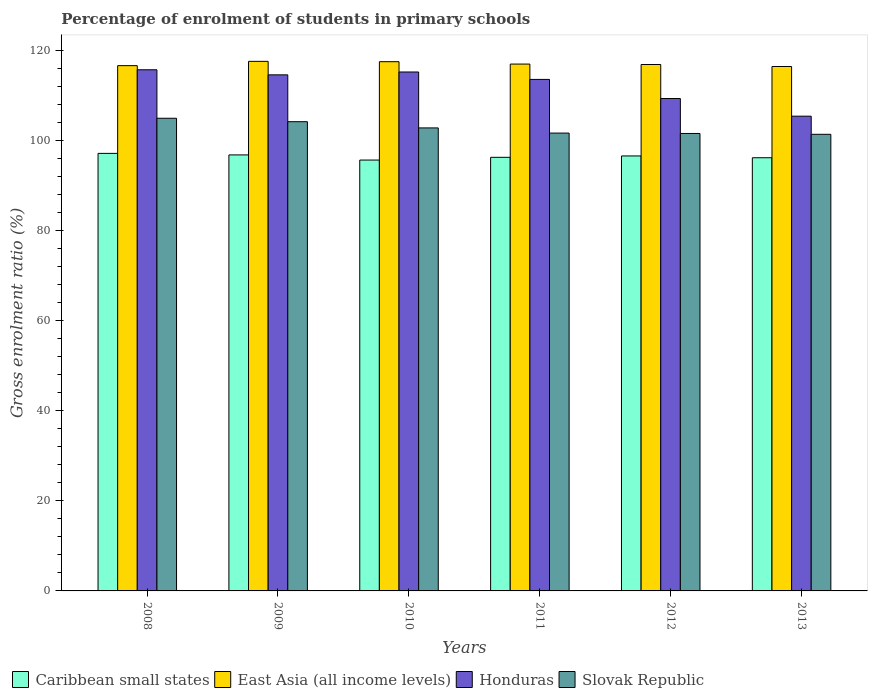Are the number of bars per tick equal to the number of legend labels?
Keep it short and to the point. Yes. How many bars are there on the 5th tick from the right?
Provide a succinct answer. 4. What is the percentage of students enrolled in primary schools in East Asia (all income levels) in 2012?
Make the answer very short. 116.97. Across all years, what is the maximum percentage of students enrolled in primary schools in Honduras?
Make the answer very short. 115.8. Across all years, what is the minimum percentage of students enrolled in primary schools in Caribbean small states?
Ensure brevity in your answer.  95.74. In which year was the percentage of students enrolled in primary schools in Slovak Republic maximum?
Make the answer very short. 2008. In which year was the percentage of students enrolled in primary schools in Caribbean small states minimum?
Your response must be concise. 2010. What is the total percentage of students enrolled in primary schools in Caribbean small states in the graph?
Provide a succinct answer. 579.08. What is the difference between the percentage of students enrolled in primary schools in Caribbean small states in 2010 and that in 2011?
Your answer should be compact. -0.61. What is the difference between the percentage of students enrolled in primary schools in Honduras in 2008 and the percentage of students enrolled in primary schools in Slovak Republic in 2013?
Provide a short and direct response. 14.34. What is the average percentage of students enrolled in primary schools in Caribbean small states per year?
Give a very brief answer. 96.51. In the year 2008, what is the difference between the percentage of students enrolled in primary schools in Slovak Republic and percentage of students enrolled in primary schools in East Asia (all income levels)?
Provide a succinct answer. -11.69. What is the ratio of the percentage of students enrolled in primary schools in Slovak Republic in 2009 to that in 2012?
Your answer should be very brief. 1.03. Is the difference between the percentage of students enrolled in primary schools in Slovak Republic in 2008 and 2013 greater than the difference between the percentage of students enrolled in primary schools in East Asia (all income levels) in 2008 and 2013?
Your answer should be compact. Yes. What is the difference between the highest and the second highest percentage of students enrolled in primary schools in Caribbean small states?
Provide a succinct answer. 0.34. What is the difference between the highest and the lowest percentage of students enrolled in primary schools in Slovak Republic?
Keep it short and to the point. 3.56. In how many years, is the percentage of students enrolled in primary schools in Caribbean small states greater than the average percentage of students enrolled in primary schools in Caribbean small states taken over all years?
Keep it short and to the point. 3. Is the sum of the percentage of students enrolled in primary schools in Honduras in 2009 and 2011 greater than the maximum percentage of students enrolled in primary schools in Caribbean small states across all years?
Provide a short and direct response. Yes. What does the 4th bar from the left in 2009 represents?
Keep it short and to the point. Slovak Republic. What does the 1st bar from the right in 2012 represents?
Keep it short and to the point. Slovak Republic. How many bars are there?
Provide a short and direct response. 24. Are all the bars in the graph horizontal?
Your answer should be very brief. No. What is the difference between two consecutive major ticks on the Y-axis?
Offer a very short reply. 20. Are the values on the major ticks of Y-axis written in scientific E-notation?
Give a very brief answer. No. How many legend labels are there?
Provide a succinct answer. 4. How are the legend labels stacked?
Your answer should be very brief. Horizontal. What is the title of the graph?
Offer a very short reply. Percentage of enrolment of students in primary schools. What is the label or title of the Y-axis?
Provide a succinct answer. Gross enrolment ratio (%). What is the Gross enrolment ratio (%) in Caribbean small states in 2008?
Ensure brevity in your answer.  97.22. What is the Gross enrolment ratio (%) in East Asia (all income levels) in 2008?
Offer a very short reply. 116.71. What is the Gross enrolment ratio (%) in Honduras in 2008?
Ensure brevity in your answer.  115.8. What is the Gross enrolment ratio (%) in Slovak Republic in 2008?
Make the answer very short. 105.02. What is the Gross enrolment ratio (%) in Caribbean small states in 2009?
Offer a very short reply. 96.88. What is the Gross enrolment ratio (%) of East Asia (all income levels) in 2009?
Make the answer very short. 117.67. What is the Gross enrolment ratio (%) of Honduras in 2009?
Offer a terse response. 114.67. What is the Gross enrolment ratio (%) in Slovak Republic in 2009?
Your response must be concise. 104.26. What is the Gross enrolment ratio (%) in Caribbean small states in 2010?
Keep it short and to the point. 95.74. What is the Gross enrolment ratio (%) in East Asia (all income levels) in 2010?
Provide a succinct answer. 117.59. What is the Gross enrolment ratio (%) in Honduras in 2010?
Give a very brief answer. 115.31. What is the Gross enrolment ratio (%) of Slovak Republic in 2010?
Your answer should be very brief. 102.88. What is the Gross enrolment ratio (%) in Caribbean small states in 2011?
Your answer should be very brief. 96.34. What is the Gross enrolment ratio (%) of East Asia (all income levels) in 2011?
Provide a succinct answer. 117.07. What is the Gross enrolment ratio (%) in Honduras in 2011?
Ensure brevity in your answer.  113.66. What is the Gross enrolment ratio (%) in Slovak Republic in 2011?
Make the answer very short. 101.73. What is the Gross enrolment ratio (%) of Caribbean small states in 2012?
Keep it short and to the point. 96.65. What is the Gross enrolment ratio (%) in East Asia (all income levels) in 2012?
Your response must be concise. 116.97. What is the Gross enrolment ratio (%) in Honduras in 2012?
Keep it short and to the point. 109.41. What is the Gross enrolment ratio (%) in Slovak Republic in 2012?
Make the answer very short. 101.65. What is the Gross enrolment ratio (%) in Caribbean small states in 2013?
Offer a very short reply. 96.25. What is the Gross enrolment ratio (%) in East Asia (all income levels) in 2013?
Ensure brevity in your answer.  116.52. What is the Gross enrolment ratio (%) in Honduras in 2013?
Give a very brief answer. 105.49. What is the Gross enrolment ratio (%) of Slovak Republic in 2013?
Your answer should be very brief. 101.46. Across all years, what is the maximum Gross enrolment ratio (%) of Caribbean small states?
Offer a very short reply. 97.22. Across all years, what is the maximum Gross enrolment ratio (%) of East Asia (all income levels)?
Make the answer very short. 117.67. Across all years, what is the maximum Gross enrolment ratio (%) in Honduras?
Give a very brief answer. 115.8. Across all years, what is the maximum Gross enrolment ratio (%) in Slovak Republic?
Your answer should be compact. 105.02. Across all years, what is the minimum Gross enrolment ratio (%) in Caribbean small states?
Offer a terse response. 95.74. Across all years, what is the minimum Gross enrolment ratio (%) in East Asia (all income levels)?
Offer a terse response. 116.52. Across all years, what is the minimum Gross enrolment ratio (%) in Honduras?
Provide a short and direct response. 105.49. Across all years, what is the minimum Gross enrolment ratio (%) in Slovak Republic?
Offer a very short reply. 101.46. What is the total Gross enrolment ratio (%) of Caribbean small states in the graph?
Your response must be concise. 579.08. What is the total Gross enrolment ratio (%) in East Asia (all income levels) in the graph?
Provide a succinct answer. 702.53. What is the total Gross enrolment ratio (%) of Honduras in the graph?
Ensure brevity in your answer.  674.33. What is the total Gross enrolment ratio (%) in Slovak Republic in the graph?
Your answer should be compact. 617. What is the difference between the Gross enrolment ratio (%) of Caribbean small states in 2008 and that in 2009?
Provide a short and direct response. 0.34. What is the difference between the Gross enrolment ratio (%) in East Asia (all income levels) in 2008 and that in 2009?
Offer a terse response. -0.95. What is the difference between the Gross enrolment ratio (%) of Honduras in 2008 and that in 2009?
Provide a succinct answer. 1.13. What is the difference between the Gross enrolment ratio (%) in Slovak Republic in 2008 and that in 2009?
Offer a very short reply. 0.76. What is the difference between the Gross enrolment ratio (%) in Caribbean small states in 2008 and that in 2010?
Make the answer very short. 1.48. What is the difference between the Gross enrolment ratio (%) in East Asia (all income levels) in 2008 and that in 2010?
Your response must be concise. -0.88. What is the difference between the Gross enrolment ratio (%) in Honduras in 2008 and that in 2010?
Make the answer very short. 0.49. What is the difference between the Gross enrolment ratio (%) in Slovak Republic in 2008 and that in 2010?
Your answer should be very brief. 2.14. What is the difference between the Gross enrolment ratio (%) of Caribbean small states in 2008 and that in 2011?
Make the answer very short. 0.88. What is the difference between the Gross enrolment ratio (%) of East Asia (all income levels) in 2008 and that in 2011?
Your response must be concise. -0.35. What is the difference between the Gross enrolment ratio (%) in Honduras in 2008 and that in 2011?
Your answer should be compact. 2.14. What is the difference between the Gross enrolment ratio (%) in Slovak Republic in 2008 and that in 2011?
Your response must be concise. 3.29. What is the difference between the Gross enrolment ratio (%) of Caribbean small states in 2008 and that in 2012?
Provide a succinct answer. 0.57. What is the difference between the Gross enrolment ratio (%) of East Asia (all income levels) in 2008 and that in 2012?
Your answer should be very brief. -0.25. What is the difference between the Gross enrolment ratio (%) of Honduras in 2008 and that in 2012?
Your answer should be compact. 6.39. What is the difference between the Gross enrolment ratio (%) of Slovak Republic in 2008 and that in 2012?
Provide a short and direct response. 3.38. What is the difference between the Gross enrolment ratio (%) of Caribbean small states in 2008 and that in 2013?
Make the answer very short. 0.97. What is the difference between the Gross enrolment ratio (%) of East Asia (all income levels) in 2008 and that in 2013?
Your answer should be compact. 0.19. What is the difference between the Gross enrolment ratio (%) of Honduras in 2008 and that in 2013?
Your answer should be very brief. 10.31. What is the difference between the Gross enrolment ratio (%) in Slovak Republic in 2008 and that in 2013?
Your answer should be very brief. 3.56. What is the difference between the Gross enrolment ratio (%) of Caribbean small states in 2009 and that in 2010?
Your answer should be compact. 1.14. What is the difference between the Gross enrolment ratio (%) in East Asia (all income levels) in 2009 and that in 2010?
Your answer should be very brief. 0.07. What is the difference between the Gross enrolment ratio (%) in Honduras in 2009 and that in 2010?
Offer a very short reply. -0.64. What is the difference between the Gross enrolment ratio (%) of Slovak Republic in 2009 and that in 2010?
Your response must be concise. 1.38. What is the difference between the Gross enrolment ratio (%) of Caribbean small states in 2009 and that in 2011?
Ensure brevity in your answer.  0.53. What is the difference between the Gross enrolment ratio (%) of East Asia (all income levels) in 2009 and that in 2011?
Your answer should be compact. 0.6. What is the difference between the Gross enrolment ratio (%) of Honduras in 2009 and that in 2011?
Offer a very short reply. 1.01. What is the difference between the Gross enrolment ratio (%) in Slovak Republic in 2009 and that in 2011?
Give a very brief answer. 2.53. What is the difference between the Gross enrolment ratio (%) in Caribbean small states in 2009 and that in 2012?
Your answer should be very brief. 0.23. What is the difference between the Gross enrolment ratio (%) in East Asia (all income levels) in 2009 and that in 2012?
Offer a terse response. 0.7. What is the difference between the Gross enrolment ratio (%) in Honduras in 2009 and that in 2012?
Your response must be concise. 5.26. What is the difference between the Gross enrolment ratio (%) in Slovak Republic in 2009 and that in 2012?
Your response must be concise. 2.61. What is the difference between the Gross enrolment ratio (%) in Caribbean small states in 2009 and that in 2013?
Provide a short and direct response. 0.63. What is the difference between the Gross enrolment ratio (%) in East Asia (all income levels) in 2009 and that in 2013?
Keep it short and to the point. 1.15. What is the difference between the Gross enrolment ratio (%) in Honduras in 2009 and that in 2013?
Make the answer very short. 9.18. What is the difference between the Gross enrolment ratio (%) of Slovak Republic in 2009 and that in 2013?
Your answer should be very brief. 2.8. What is the difference between the Gross enrolment ratio (%) in Caribbean small states in 2010 and that in 2011?
Your response must be concise. -0.61. What is the difference between the Gross enrolment ratio (%) of East Asia (all income levels) in 2010 and that in 2011?
Ensure brevity in your answer.  0.53. What is the difference between the Gross enrolment ratio (%) in Honduras in 2010 and that in 2011?
Your answer should be very brief. 1.65. What is the difference between the Gross enrolment ratio (%) of Slovak Republic in 2010 and that in 2011?
Make the answer very short. 1.15. What is the difference between the Gross enrolment ratio (%) of Caribbean small states in 2010 and that in 2012?
Give a very brief answer. -0.92. What is the difference between the Gross enrolment ratio (%) in East Asia (all income levels) in 2010 and that in 2012?
Your response must be concise. 0.63. What is the difference between the Gross enrolment ratio (%) in Honduras in 2010 and that in 2012?
Offer a very short reply. 5.89. What is the difference between the Gross enrolment ratio (%) of Slovak Republic in 2010 and that in 2012?
Ensure brevity in your answer.  1.23. What is the difference between the Gross enrolment ratio (%) of Caribbean small states in 2010 and that in 2013?
Make the answer very short. -0.52. What is the difference between the Gross enrolment ratio (%) in East Asia (all income levels) in 2010 and that in 2013?
Ensure brevity in your answer.  1.07. What is the difference between the Gross enrolment ratio (%) in Honduras in 2010 and that in 2013?
Make the answer very short. 9.82. What is the difference between the Gross enrolment ratio (%) in Slovak Republic in 2010 and that in 2013?
Provide a succinct answer. 1.42. What is the difference between the Gross enrolment ratio (%) of Caribbean small states in 2011 and that in 2012?
Make the answer very short. -0.31. What is the difference between the Gross enrolment ratio (%) of East Asia (all income levels) in 2011 and that in 2012?
Your answer should be compact. 0.1. What is the difference between the Gross enrolment ratio (%) of Honduras in 2011 and that in 2012?
Provide a succinct answer. 4.25. What is the difference between the Gross enrolment ratio (%) in Slovak Republic in 2011 and that in 2012?
Offer a terse response. 0.08. What is the difference between the Gross enrolment ratio (%) in Caribbean small states in 2011 and that in 2013?
Your response must be concise. 0.09. What is the difference between the Gross enrolment ratio (%) in East Asia (all income levels) in 2011 and that in 2013?
Your answer should be compact. 0.54. What is the difference between the Gross enrolment ratio (%) in Honduras in 2011 and that in 2013?
Keep it short and to the point. 8.17. What is the difference between the Gross enrolment ratio (%) in Slovak Republic in 2011 and that in 2013?
Offer a very short reply. 0.27. What is the difference between the Gross enrolment ratio (%) of Caribbean small states in 2012 and that in 2013?
Your response must be concise. 0.4. What is the difference between the Gross enrolment ratio (%) in East Asia (all income levels) in 2012 and that in 2013?
Provide a short and direct response. 0.45. What is the difference between the Gross enrolment ratio (%) in Honduras in 2012 and that in 2013?
Your answer should be compact. 3.93. What is the difference between the Gross enrolment ratio (%) of Slovak Republic in 2012 and that in 2013?
Offer a terse response. 0.19. What is the difference between the Gross enrolment ratio (%) in Caribbean small states in 2008 and the Gross enrolment ratio (%) in East Asia (all income levels) in 2009?
Your answer should be very brief. -20.45. What is the difference between the Gross enrolment ratio (%) in Caribbean small states in 2008 and the Gross enrolment ratio (%) in Honduras in 2009?
Provide a short and direct response. -17.45. What is the difference between the Gross enrolment ratio (%) in Caribbean small states in 2008 and the Gross enrolment ratio (%) in Slovak Republic in 2009?
Offer a very short reply. -7.04. What is the difference between the Gross enrolment ratio (%) in East Asia (all income levels) in 2008 and the Gross enrolment ratio (%) in Honduras in 2009?
Offer a very short reply. 2.04. What is the difference between the Gross enrolment ratio (%) in East Asia (all income levels) in 2008 and the Gross enrolment ratio (%) in Slovak Republic in 2009?
Give a very brief answer. 12.45. What is the difference between the Gross enrolment ratio (%) of Honduras in 2008 and the Gross enrolment ratio (%) of Slovak Republic in 2009?
Provide a short and direct response. 11.54. What is the difference between the Gross enrolment ratio (%) of Caribbean small states in 2008 and the Gross enrolment ratio (%) of East Asia (all income levels) in 2010?
Keep it short and to the point. -20.37. What is the difference between the Gross enrolment ratio (%) of Caribbean small states in 2008 and the Gross enrolment ratio (%) of Honduras in 2010?
Provide a succinct answer. -18.09. What is the difference between the Gross enrolment ratio (%) of Caribbean small states in 2008 and the Gross enrolment ratio (%) of Slovak Republic in 2010?
Your answer should be compact. -5.66. What is the difference between the Gross enrolment ratio (%) of East Asia (all income levels) in 2008 and the Gross enrolment ratio (%) of Honduras in 2010?
Keep it short and to the point. 1.41. What is the difference between the Gross enrolment ratio (%) in East Asia (all income levels) in 2008 and the Gross enrolment ratio (%) in Slovak Republic in 2010?
Provide a short and direct response. 13.83. What is the difference between the Gross enrolment ratio (%) in Honduras in 2008 and the Gross enrolment ratio (%) in Slovak Republic in 2010?
Your answer should be compact. 12.92. What is the difference between the Gross enrolment ratio (%) of Caribbean small states in 2008 and the Gross enrolment ratio (%) of East Asia (all income levels) in 2011?
Your answer should be very brief. -19.85. What is the difference between the Gross enrolment ratio (%) in Caribbean small states in 2008 and the Gross enrolment ratio (%) in Honduras in 2011?
Offer a very short reply. -16.44. What is the difference between the Gross enrolment ratio (%) in Caribbean small states in 2008 and the Gross enrolment ratio (%) in Slovak Republic in 2011?
Provide a succinct answer. -4.51. What is the difference between the Gross enrolment ratio (%) in East Asia (all income levels) in 2008 and the Gross enrolment ratio (%) in Honduras in 2011?
Your answer should be very brief. 3.06. What is the difference between the Gross enrolment ratio (%) of East Asia (all income levels) in 2008 and the Gross enrolment ratio (%) of Slovak Republic in 2011?
Ensure brevity in your answer.  14.98. What is the difference between the Gross enrolment ratio (%) of Honduras in 2008 and the Gross enrolment ratio (%) of Slovak Republic in 2011?
Your response must be concise. 14.07. What is the difference between the Gross enrolment ratio (%) in Caribbean small states in 2008 and the Gross enrolment ratio (%) in East Asia (all income levels) in 2012?
Your answer should be compact. -19.75. What is the difference between the Gross enrolment ratio (%) in Caribbean small states in 2008 and the Gross enrolment ratio (%) in Honduras in 2012?
Offer a very short reply. -12.19. What is the difference between the Gross enrolment ratio (%) of Caribbean small states in 2008 and the Gross enrolment ratio (%) of Slovak Republic in 2012?
Keep it short and to the point. -4.43. What is the difference between the Gross enrolment ratio (%) in East Asia (all income levels) in 2008 and the Gross enrolment ratio (%) in Honduras in 2012?
Your response must be concise. 7.3. What is the difference between the Gross enrolment ratio (%) of East Asia (all income levels) in 2008 and the Gross enrolment ratio (%) of Slovak Republic in 2012?
Your answer should be very brief. 15.07. What is the difference between the Gross enrolment ratio (%) in Honduras in 2008 and the Gross enrolment ratio (%) in Slovak Republic in 2012?
Make the answer very short. 14.15. What is the difference between the Gross enrolment ratio (%) in Caribbean small states in 2008 and the Gross enrolment ratio (%) in East Asia (all income levels) in 2013?
Provide a short and direct response. -19.3. What is the difference between the Gross enrolment ratio (%) of Caribbean small states in 2008 and the Gross enrolment ratio (%) of Honduras in 2013?
Your answer should be very brief. -8.27. What is the difference between the Gross enrolment ratio (%) of Caribbean small states in 2008 and the Gross enrolment ratio (%) of Slovak Republic in 2013?
Keep it short and to the point. -4.24. What is the difference between the Gross enrolment ratio (%) in East Asia (all income levels) in 2008 and the Gross enrolment ratio (%) in Honduras in 2013?
Your answer should be compact. 11.23. What is the difference between the Gross enrolment ratio (%) of East Asia (all income levels) in 2008 and the Gross enrolment ratio (%) of Slovak Republic in 2013?
Make the answer very short. 15.25. What is the difference between the Gross enrolment ratio (%) in Honduras in 2008 and the Gross enrolment ratio (%) in Slovak Republic in 2013?
Keep it short and to the point. 14.34. What is the difference between the Gross enrolment ratio (%) of Caribbean small states in 2009 and the Gross enrolment ratio (%) of East Asia (all income levels) in 2010?
Make the answer very short. -20.72. What is the difference between the Gross enrolment ratio (%) of Caribbean small states in 2009 and the Gross enrolment ratio (%) of Honduras in 2010?
Provide a succinct answer. -18.43. What is the difference between the Gross enrolment ratio (%) in Caribbean small states in 2009 and the Gross enrolment ratio (%) in Slovak Republic in 2010?
Provide a short and direct response. -6. What is the difference between the Gross enrolment ratio (%) in East Asia (all income levels) in 2009 and the Gross enrolment ratio (%) in Honduras in 2010?
Make the answer very short. 2.36. What is the difference between the Gross enrolment ratio (%) of East Asia (all income levels) in 2009 and the Gross enrolment ratio (%) of Slovak Republic in 2010?
Offer a very short reply. 14.79. What is the difference between the Gross enrolment ratio (%) of Honduras in 2009 and the Gross enrolment ratio (%) of Slovak Republic in 2010?
Ensure brevity in your answer.  11.79. What is the difference between the Gross enrolment ratio (%) of Caribbean small states in 2009 and the Gross enrolment ratio (%) of East Asia (all income levels) in 2011?
Give a very brief answer. -20.19. What is the difference between the Gross enrolment ratio (%) of Caribbean small states in 2009 and the Gross enrolment ratio (%) of Honduras in 2011?
Keep it short and to the point. -16.78. What is the difference between the Gross enrolment ratio (%) in Caribbean small states in 2009 and the Gross enrolment ratio (%) in Slovak Republic in 2011?
Your answer should be very brief. -4.85. What is the difference between the Gross enrolment ratio (%) of East Asia (all income levels) in 2009 and the Gross enrolment ratio (%) of Honduras in 2011?
Ensure brevity in your answer.  4.01. What is the difference between the Gross enrolment ratio (%) of East Asia (all income levels) in 2009 and the Gross enrolment ratio (%) of Slovak Republic in 2011?
Give a very brief answer. 15.94. What is the difference between the Gross enrolment ratio (%) of Honduras in 2009 and the Gross enrolment ratio (%) of Slovak Republic in 2011?
Provide a short and direct response. 12.94. What is the difference between the Gross enrolment ratio (%) in Caribbean small states in 2009 and the Gross enrolment ratio (%) in East Asia (all income levels) in 2012?
Offer a terse response. -20.09. What is the difference between the Gross enrolment ratio (%) of Caribbean small states in 2009 and the Gross enrolment ratio (%) of Honduras in 2012?
Your response must be concise. -12.53. What is the difference between the Gross enrolment ratio (%) in Caribbean small states in 2009 and the Gross enrolment ratio (%) in Slovak Republic in 2012?
Make the answer very short. -4.77. What is the difference between the Gross enrolment ratio (%) of East Asia (all income levels) in 2009 and the Gross enrolment ratio (%) of Honduras in 2012?
Ensure brevity in your answer.  8.26. What is the difference between the Gross enrolment ratio (%) of East Asia (all income levels) in 2009 and the Gross enrolment ratio (%) of Slovak Republic in 2012?
Provide a short and direct response. 16.02. What is the difference between the Gross enrolment ratio (%) in Honduras in 2009 and the Gross enrolment ratio (%) in Slovak Republic in 2012?
Ensure brevity in your answer.  13.02. What is the difference between the Gross enrolment ratio (%) of Caribbean small states in 2009 and the Gross enrolment ratio (%) of East Asia (all income levels) in 2013?
Your answer should be very brief. -19.64. What is the difference between the Gross enrolment ratio (%) in Caribbean small states in 2009 and the Gross enrolment ratio (%) in Honduras in 2013?
Give a very brief answer. -8.61. What is the difference between the Gross enrolment ratio (%) of Caribbean small states in 2009 and the Gross enrolment ratio (%) of Slovak Republic in 2013?
Offer a terse response. -4.58. What is the difference between the Gross enrolment ratio (%) of East Asia (all income levels) in 2009 and the Gross enrolment ratio (%) of Honduras in 2013?
Your response must be concise. 12.18. What is the difference between the Gross enrolment ratio (%) in East Asia (all income levels) in 2009 and the Gross enrolment ratio (%) in Slovak Republic in 2013?
Give a very brief answer. 16.21. What is the difference between the Gross enrolment ratio (%) in Honduras in 2009 and the Gross enrolment ratio (%) in Slovak Republic in 2013?
Make the answer very short. 13.21. What is the difference between the Gross enrolment ratio (%) in Caribbean small states in 2010 and the Gross enrolment ratio (%) in East Asia (all income levels) in 2011?
Make the answer very short. -21.33. What is the difference between the Gross enrolment ratio (%) in Caribbean small states in 2010 and the Gross enrolment ratio (%) in Honduras in 2011?
Give a very brief answer. -17.92. What is the difference between the Gross enrolment ratio (%) in Caribbean small states in 2010 and the Gross enrolment ratio (%) in Slovak Republic in 2011?
Provide a short and direct response. -5.99. What is the difference between the Gross enrolment ratio (%) in East Asia (all income levels) in 2010 and the Gross enrolment ratio (%) in Honduras in 2011?
Your response must be concise. 3.94. What is the difference between the Gross enrolment ratio (%) of East Asia (all income levels) in 2010 and the Gross enrolment ratio (%) of Slovak Republic in 2011?
Your response must be concise. 15.86. What is the difference between the Gross enrolment ratio (%) of Honduras in 2010 and the Gross enrolment ratio (%) of Slovak Republic in 2011?
Provide a succinct answer. 13.58. What is the difference between the Gross enrolment ratio (%) in Caribbean small states in 2010 and the Gross enrolment ratio (%) in East Asia (all income levels) in 2012?
Your response must be concise. -21.23. What is the difference between the Gross enrolment ratio (%) in Caribbean small states in 2010 and the Gross enrolment ratio (%) in Honduras in 2012?
Your response must be concise. -13.67. What is the difference between the Gross enrolment ratio (%) in Caribbean small states in 2010 and the Gross enrolment ratio (%) in Slovak Republic in 2012?
Offer a very short reply. -5.91. What is the difference between the Gross enrolment ratio (%) of East Asia (all income levels) in 2010 and the Gross enrolment ratio (%) of Honduras in 2012?
Provide a succinct answer. 8.18. What is the difference between the Gross enrolment ratio (%) in East Asia (all income levels) in 2010 and the Gross enrolment ratio (%) in Slovak Republic in 2012?
Offer a very short reply. 15.95. What is the difference between the Gross enrolment ratio (%) of Honduras in 2010 and the Gross enrolment ratio (%) of Slovak Republic in 2012?
Offer a very short reply. 13.66. What is the difference between the Gross enrolment ratio (%) in Caribbean small states in 2010 and the Gross enrolment ratio (%) in East Asia (all income levels) in 2013?
Provide a short and direct response. -20.79. What is the difference between the Gross enrolment ratio (%) of Caribbean small states in 2010 and the Gross enrolment ratio (%) of Honduras in 2013?
Your answer should be very brief. -9.75. What is the difference between the Gross enrolment ratio (%) of Caribbean small states in 2010 and the Gross enrolment ratio (%) of Slovak Republic in 2013?
Keep it short and to the point. -5.72. What is the difference between the Gross enrolment ratio (%) in East Asia (all income levels) in 2010 and the Gross enrolment ratio (%) in Honduras in 2013?
Make the answer very short. 12.11. What is the difference between the Gross enrolment ratio (%) in East Asia (all income levels) in 2010 and the Gross enrolment ratio (%) in Slovak Republic in 2013?
Your answer should be very brief. 16.13. What is the difference between the Gross enrolment ratio (%) in Honduras in 2010 and the Gross enrolment ratio (%) in Slovak Republic in 2013?
Provide a succinct answer. 13.85. What is the difference between the Gross enrolment ratio (%) in Caribbean small states in 2011 and the Gross enrolment ratio (%) in East Asia (all income levels) in 2012?
Your answer should be very brief. -20.62. What is the difference between the Gross enrolment ratio (%) of Caribbean small states in 2011 and the Gross enrolment ratio (%) of Honduras in 2012?
Make the answer very short. -13.07. What is the difference between the Gross enrolment ratio (%) of Caribbean small states in 2011 and the Gross enrolment ratio (%) of Slovak Republic in 2012?
Your answer should be compact. -5.3. What is the difference between the Gross enrolment ratio (%) of East Asia (all income levels) in 2011 and the Gross enrolment ratio (%) of Honduras in 2012?
Provide a succinct answer. 7.66. What is the difference between the Gross enrolment ratio (%) in East Asia (all income levels) in 2011 and the Gross enrolment ratio (%) in Slovak Republic in 2012?
Provide a succinct answer. 15.42. What is the difference between the Gross enrolment ratio (%) of Honduras in 2011 and the Gross enrolment ratio (%) of Slovak Republic in 2012?
Offer a very short reply. 12.01. What is the difference between the Gross enrolment ratio (%) of Caribbean small states in 2011 and the Gross enrolment ratio (%) of East Asia (all income levels) in 2013?
Offer a terse response. -20.18. What is the difference between the Gross enrolment ratio (%) in Caribbean small states in 2011 and the Gross enrolment ratio (%) in Honduras in 2013?
Provide a succinct answer. -9.14. What is the difference between the Gross enrolment ratio (%) in Caribbean small states in 2011 and the Gross enrolment ratio (%) in Slovak Republic in 2013?
Ensure brevity in your answer.  -5.12. What is the difference between the Gross enrolment ratio (%) of East Asia (all income levels) in 2011 and the Gross enrolment ratio (%) of Honduras in 2013?
Your answer should be very brief. 11.58. What is the difference between the Gross enrolment ratio (%) in East Asia (all income levels) in 2011 and the Gross enrolment ratio (%) in Slovak Republic in 2013?
Provide a short and direct response. 15.61. What is the difference between the Gross enrolment ratio (%) of Honduras in 2011 and the Gross enrolment ratio (%) of Slovak Republic in 2013?
Your answer should be very brief. 12.2. What is the difference between the Gross enrolment ratio (%) in Caribbean small states in 2012 and the Gross enrolment ratio (%) in East Asia (all income levels) in 2013?
Provide a succinct answer. -19.87. What is the difference between the Gross enrolment ratio (%) of Caribbean small states in 2012 and the Gross enrolment ratio (%) of Honduras in 2013?
Offer a very short reply. -8.83. What is the difference between the Gross enrolment ratio (%) in Caribbean small states in 2012 and the Gross enrolment ratio (%) in Slovak Republic in 2013?
Offer a very short reply. -4.81. What is the difference between the Gross enrolment ratio (%) in East Asia (all income levels) in 2012 and the Gross enrolment ratio (%) in Honduras in 2013?
Give a very brief answer. 11.48. What is the difference between the Gross enrolment ratio (%) in East Asia (all income levels) in 2012 and the Gross enrolment ratio (%) in Slovak Republic in 2013?
Offer a very short reply. 15.51. What is the difference between the Gross enrolment ratio (%) in Honduras in 2012 and the Gross enrolment ratio (%) in Slovak Republic in 2013?
Offer a terse response. 7.95. What is the average Gross enrolment ratio (%) in Caribbean small states per year?
Provide a short and direct response. 96.51. What is the average Gross enrolment ratio (%) of East Asia (all income levels) per year?
Offer a terse response. 117.09. What is the average Gross enrolment ratio (%) of Honduras per year?
Your answer should be compact. 112.39. What is the average Gross enrolment ratio (%) in Slovak Republic per year?
Your answer should be very brief. 102.83. In the year 2008, what is the difference between the Gross enrolment ratio (%) in Caribbean small states and Gross enrolment ratio (%) in East Asia (all income levels)?
Offer a very short reply. -19.49. In the year 2008, what is the difference between the Gross enrolment ratio (%) of Caribbean small states and Gross enrolment ratio (%) of Honduras?
Your answer should be compact. -18.58. In the year 2008, what is the difference between the Gross enrolment ratio (%) of Caribbean small states and Gross enrolment ratio (%) of Slovak Republic?
Your answer should be compact. -7.8. In the year 2008, what is the difference between the Gross enrolment ratio (%) of East Asia (all income levels) and Gross enrolment ratio (%) of Honduras?
Give a very brief answer. 0.92. In the year 2008, what is the difference between the Gross enrolment ratio (%) in East Asia (all income levels) and Gross enrolment ratio (%) in Slovak Republic?
Provide a succinct answer. 11.69. In the year 2008, what is the difference between the Gross enrolment ratio (%) of Honduras and Gross enrolment ratio (%) of Slovak Republic?
Make the answer very short. 10.77. In the year 2009, what is the difference between the Gross enrolment ratio (%) of Caribbean small states and Gross enrolment ratio (%) of East Asia (all income levels)?
Provide a short and direct response. -20.79. In the year 2009, what is the difference between the Gross enrolment ratio (%) of Caribbean small states and Gross enrolment ratio (%) of Honduras?
Your answer should be very brief. -17.79. In the year 2009, what is the difference between the Gross enrolment ratio (%) of Caribbean small states and Gross enrolment ratio (%) of Slovak Republic?
Offer a terse response. -7.38. In the year 2009, what is the difference between the Gross enrolment ratio (%) in East Asia (all income levels) and Gross enrolment ratio (%) in Honduras?
Offer a terse response. 3. In the year 2009, what is the difference between the Gross enrolment ratio (%) in East Asia (all income levels) and Gross enrolment ratio (%) in Slovak Republic?
Ensure brevity in your answer.  13.41. In the year 2009, what is the difference between the Gross enrolment ratio (%) of Honduras and Gross enrolment ratio (%) of Slovak Republic?
Offer a very short reply. 10.41. In the year 2010, what is the difference between the Gross enrolment ratio (%) in Caribbean small states and Gross enrolment ratio (%) in East Asia (all income levels)?
Ensure brevity in your answer.  -21.86. In the year 2010, what is the difference between the Gross enrolment ratio (%) of Caribbean small states and Gross enrolment ratio (%) of Honduras?
Provide a short and direct response. -19.57. In the year 2010, what is the difference between the Gross enrolment ratio (%) of Caribbean small states and Gross enrolment ratio (%) of Slovak Republic?
Your answer should be very brief. -7.14. In the year 2010, what is the difference between the Gross enrolment ratio (%) of East Asia (all income levels) and Gross enrolment ratio (%) of Honduras?
Provide a succinct answer. 2.29. In the year 2010, what is the difference between the Gross enrolment ratio (%) of East Asia (all income levels) and Gross enrolment ratio (%) of Slovak Republic?
Your answer should be very brief. 14.71. In the year 2010, what is the difference between the Gross enrolment ratio (%) in Honduras and Gross enrolment ratio (%) in Slovak Republic?
Offer a terse response. 12.43. In the year 2011, what is the difference between the Gross enrolment ratio (%) of Caribbean small states and Gross enrolment ratio (%) of East Asia (all income levels)?
Keep it short and to the point. -20.72. In the year 2011, what is the difference between the Gross enrolment ratio (%) of Caribbean small states and Gross enrolment ratio (%) of Honduras?
Offer a very short reply. -17.31. In the year 2011, what is the difference between the Gross enrolment ratio (%) in Caribbean small states and Gross enrolment ratio (%) in Slovak Republic?
Make the answer very short. -5.39. In the year 2011, what is the difference between the Gross enrolment ratio (%) of East Asia (all income levels) and Gross enrolment ratio (%) of Honduras?
Ensure brevity in your answer.  3.41. In the year 2011, what is the difference between the Gross enrolment ratio (%) in East Asia (all income levels) and Gross enrolment ratio (%) in Slovak Republic?
Your response must be concise. 15.34. In the year 2011, what is the difference between the Gross enrolment ratio (%) of Honduras and Gross enrolment ratio (%) of Slovak Republic?
Provide a succinct answer. 11.93. In the year 2012, what is the difference between the Gross enrolment ratio (%) of Caribbean small states and Gross enrolment ratio (%) of East Asia (all income levels)?
Your response must be concise. -20.32. In the year 2012, what is the difference between the Gross enrolment ratio (%) of Caribbean small states and Gross enrolment ratio (%) of Honduras?
Provide a short and direct response. -12.76. In the year 2012, what is the difference between the Gross enrolment ratio (%) of Caribbean small states and Gross enrolment ratio (%) of Slovak Republic?
Keep it short and to the point. -5. In the year 2012, what is the difference between the Gross enrolment ratio (%) of East Asia (all income levels) and Gross enrolment ratio (%) of Honduras?
Provide a succinct answer. 7.56. In the year 2012, what is the difference between the Gross enrolment ratio (%) of East Asia (all income levels) and Gross enrolment ratio (%) of Slovak Republic?
Ensure brevity in your answer.  15.32. In the year 2012, what is the difference between the Gross enrolment ratio (%) of Honduras and Gross enrolment ratio (%) of Slovak Republic?
Offer a terse response. 7.76. In the year 2013, what is the difference between the Gross enrolment ratio (%) of Caribbean small states and Gross enrolment ratio (%) of East Asia (all income levels)?
Your answer should be compact. -20.27. In the year 2013, what is the difference between the Gross enrolment ratio (%) in Caribbean small states and Gross enrolment ratio (%) in Honduras?
Your answer should be compact. -9.23. In the year 2013, what is the difference between the Gross enrolment ratio (%) in Caribbean small states and Gross enrolment ratio (%) in Slovak Republic?
Provide a short and direct response. -5.21. In the year 2013, what is the difference between the Gross enrolment ratio (%) of East Asia (all income levels) and Gross enrolment ratio (%) of Honduras?
Provide a short and direct response. 11.04. In the year 2013, what is the difference between the Gross enrolment ratio (%) of East Asia (all income levels) and Gross enrolment ratio (%) of Slovak Republic?
Offer a terse response. 15.06. In the year 2013, what is the difference between the Gross enrolment ratio (%) of Honduras and Gross enrolment ratio (%) of Slovak Republic?
Your answer should be very brief. 4.03. What is the ratio of the Gross enrolment ratio (%) in Caribbean small states in 2008 to that in 2009?
Your answer should be compact. 1. What is the ratio of the Gross enrolment ratio (%) in Honduras in 2008 to that in 2009?
Offer a terse response. 1.01. What is the ratio of the Gross enrolment ratio (%) in Slovak Republic in 2008 to that in 2009?
Provide a succinct answer. 1.01. What is the ratio of the Gross enrolment ratio (%) in Caribbean small states in 2008 to that in 2010?
Offer a terse response. 1.02. What is the ratio of the Gross enrolment ratio (%) of East Asia (all income levels) in 2008 to that in 2010?
Keep it short and to the point. 0.99. What is the ratio of the Gross enrolment ratio (%) in Slovak Republic in 2008 to that in 2010?
Provide a short and direct response. 1.02. What is the ratio of the Gross enrolment ratio (%) in Caribbean small states in 2008 to that in 2011?
Offer a very short reply. 1.01. What is the ratio of the Gross enrolment ratio (%) of Honduras in 2008 to that in 2011?
Provide a short and direct response. 1.02. What is the ratio of the Gross enrolment ratio (%) of Slovak Republic in 2008 to that in 2011?
Keep it short and to the point. 1.03. What is the ratio of the Gross enrolment ratio (%) in Caribbean small states in 2008 to that in 2012?
Provide a succinct answer. 1.01. What is the ratio of the Gross enrolment ratio (%) of East Asia (all income levels) in 2008 to that in 2012?
Provide a succinct answer. 1. What is the ratio of the Gross enrolment ratio (%) in Honduras in 2008 to that in 2012?
Offer a terse response. 1.06. What is the ratio of the Gross enrolment ratio (%) of Slovak Republic in 2008 to that in 2012?
Provide a succinct answer. 1.03. What is the ratio of the Gross enrolment ratio (%) in Caribbean small states in 2008 to that in 2013?
Provide a short and direct response. 1.01. What is the ratio of the Gross enrolment ratio (%) of Honduras in 2008 to that in 2013?
Your response must be concise. 1.1. What is the ratio of the Gross enrolment ratio (%) in Slovak Republic in 2008 to that in 2013?
Keep it short and to the point. 1.04. What is the ratio of the Gross enrolment ratio (%) of Caribbean small states in 2009 to that in 2010?
Offer a very short reply. 1.01. What is the ratio of the Gross enrolment ratio (%) in Honduras in 2009 to that in 2010?
Give a very brief answer. 0.99. What is the ratio of the Gross enrolment ratio (%) in Slovak Republic in 2009 to that in 2010?
Your answer should be very brief. 1.01. What is the ratio of the Gross enrolment ratio (%) of Honduras in 2009 to that in 2011?
Offer a terse response. 1.01. What is the ratio of the Gross enrolment ratio (%) of Slovak Republic in 2009 to that in 2011?
Offer a terse response. 1.02. What is the ratio of the Gross enrolment ratio (%) in Honduras in 2009 to that in 2012?
Give a very brief answer. 1.05. What is the ratio of the Gross enrolment ratio (%) of Slovak Republic in 2009 to that in 2012?
Make the answer very short. 1.03. What is the ratio of the Gross enrolment ratio (%) of Caribbean small states in 2009 to that in 2013?
Provide a short and direct response. 1.01. What is the ratio of the Gross enrolment ratio (%) of East Asia (all income levels) in 2009 to that in 2013?
Offer a very short reply. 1.01. What is the ratio of the Gross enrolment ratio (%) in Honduras in 2009 to that in 2013?
Give a very brief answer. 1.09. What is the ratio of the Gross enrolment ratio (%) of Slovak Republic in 2009 to that in 2013?
Make the answer very short. 1.03. What is the ratio of the Gross enrolment ratio (%) in East Asia (all income levels) in 2010 to that in 2011?
Your answer should be very brief. 1. What is the ratio of the Gross enrolment ratio (%) in Honduras in 2010 to that in 2011?
Offer a very short reply. 1.01. What is the ratio of the Gross enrolment ratio (%) in Slovak Republic in 2010 to that in 2011?
Your answer should be compact. 1.01. What is the ratio of the Gross enrolment ratio (%) of Caribbean small states in 2010 to that in 2012?
Give a very brief answer. 0.99. What is the ratio of the Gross enrolment ratio (%) of Honduras in 2010 to that in 2012?
Offer a very short reply. 1.05. What is the ratio of the Gross enrolment ratio (%) in Slovak Republic in 2010 to that in 2012?
Ensure brevity in your answer.  1.01. What is the ratio of the Gross enrolment ratio (%) of East Asia (all income levels) in 2010 to that in 2013?
Your answer should be compact. 1.01. What is the ratio of the Gross enrolment ratio (%) in Honduras in 2010 to that in 2013?
Give a very brief answer. 1.09. What is the ratio of the Gross enrolment ratio (%) of Slovak Republic in 2010 to that in 2013?
Offer a very short reply. 1.01. What is the ratio of the Gross enrolment ratio (%) in Caribbean small states in 2011 to that in 2012?
Make the answer very short. 1. What is the ratio of the Gross enrolment ratio (%) in East Asia (all income levels) in 2011 to that in 2012?
Your answer should be compact. 1. What is the ratio of the Gross enrolment ratio (%) of Honduras in 2011 to that in 2012?
Ensure brevity in your answer.  1.04. What is the ratio of the Gross enrolment ratio (%) in Caribbean small states in 2011 to that in 2013?
Provide a short and direct response. 1. What is the ratio of the Gross enrolment ratio (%) in Honduras in 2011 to that in 2013?
Your response must be concise. 1.08. What is the ratio of the Gross enrolment ratio (%) in East Asia (all income levels) in 2012 to that in 2013?
Give a very brief answer. 1. What is the ratio of the Gross enrolment ratio (%) in Honduras in 2012 to that in 2013?
Offer a terse response. 1.04. What is the difference between the highest and the second highest Gross enrolment ratio (%) of Caribbean small states?
Your answer should be compact. 0.34. What is the difference between the highest and the second highest Gross enrolment ratio (%) in East Asia (all income levels)?
Give a very brief answer. 0.07. What is the difference between the highest and the second highest Gross enrolment ratio (%) in Honduras?
Offer a terse response. 0.49. What is the difference between the highest and the second highest Gross enrolment ratio (%) of Slovak Republic?
Keep it short and to the point. 0.76. What is the difference between the highest and the lowest Gross enrolment ratio (%) in Caribbean small states?
Provide a short and direct response. 1.48. What is the difference between the highest and the lowest Gross enrolment ratio (%) of East Asia (all income levels)?
Keep it short and to the point. 1.15. What is the difference between the highest and the lowest Gross enrolment ratio (%) in Honduras?
Make the answer very short. 10.31. What is the difference between the highest and the lowest Gross enrolment ratio (%) in Slovak Republic?
Give a very brief answer. 3.56. 